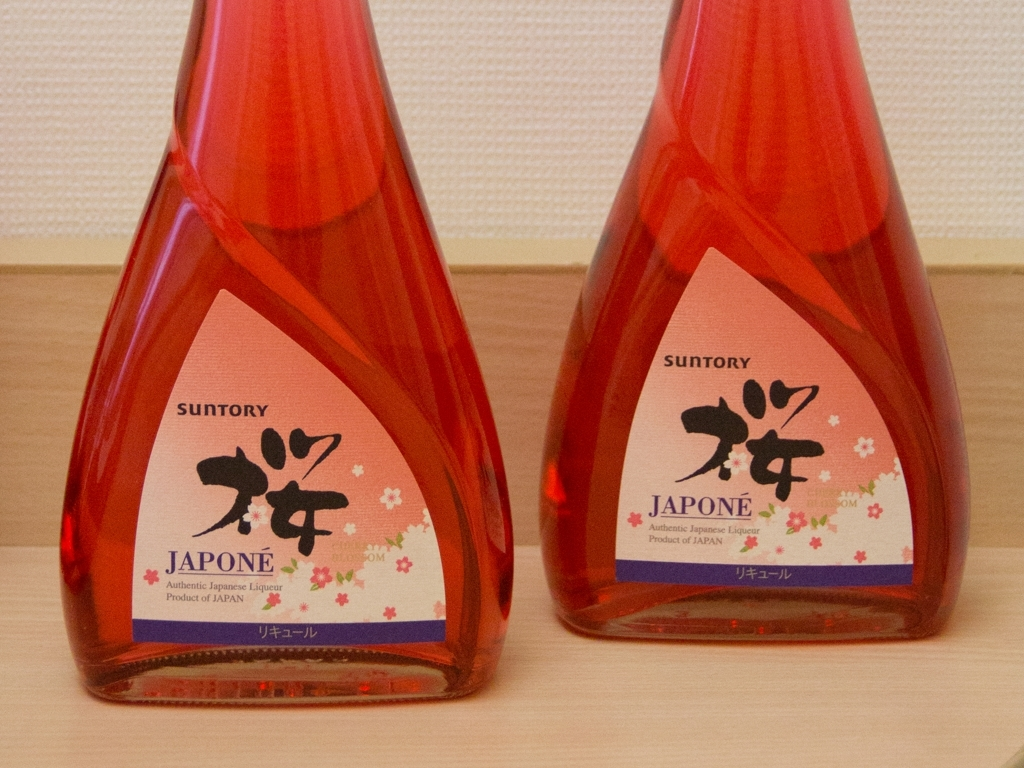Are the colors in the image vibrant?
A. Yes
B. No
Answer with the option's letter from the given choices directly.
 B. 